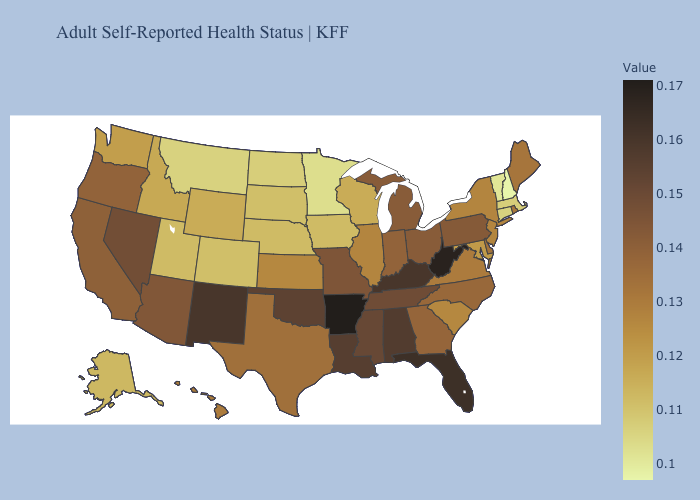Does Missouri have a lower value than New Jersey?
Keep it brief. No. Does New Mexico have the highest value in the West?
Answer briefly. Yes. Among the states that border Minnesota , which have the lowest value?
Answer briefly. North Dakota. Among the states that border Louisiana , does Mississippi have the highest value?
Keep it brief. No. Does Delaware have the highest value in the South?
Give a very brief answer. No. Among the states that border Vermont , which have the highest value?
Answer briefly. New York. Among the states that border North Dakota , does Minnesota have the lowest value?
Keep it brief. Yes. Which states have the highest value in the USA?
Be succinct. Arkansas. 